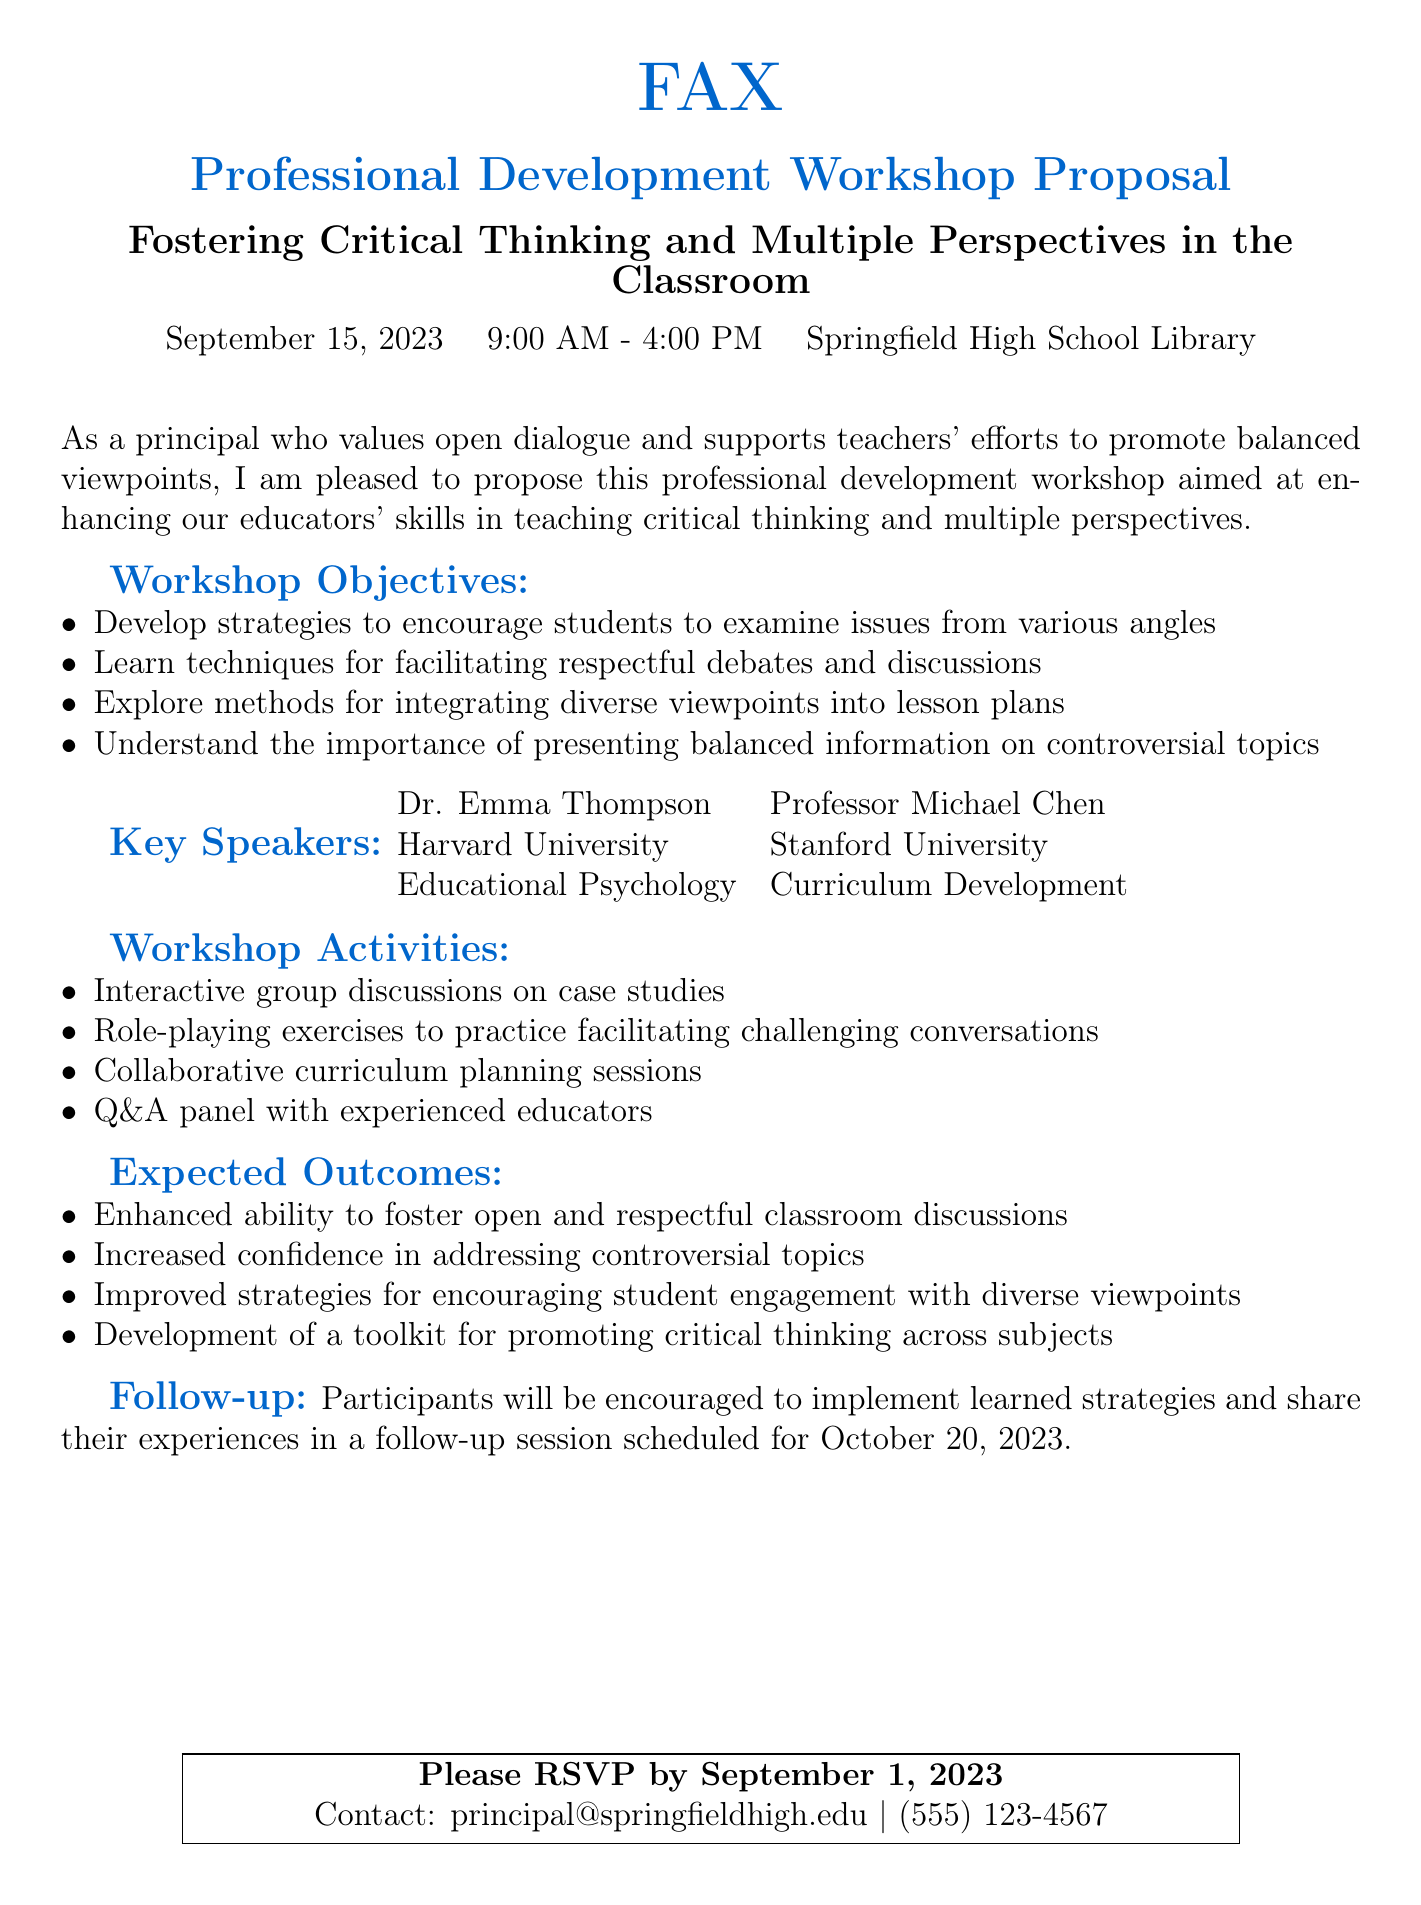What is the date of the workshop? The workshop is scheduled for September 15, 2023, as mentioned in the document.
Answer: September 15, 2023 What is the duration of the workshop? The workshop starts at 9:00 AM and ends at 4:00 PM, indicating a duration of 7 hours.
Answer: 7 hours Who is one of the key speakers? Dr. Emma Thompson is listed as one of the key speakers in the workshop proposal.
Answer: Dr. Emma Thompson What is one objective of the workshop? The document lists several objectives, one being to develop strategies to encourage students to examine issues from various angles.
Answer: Encourage students to examine issues from various angles What is the RSVP deadline? The document specifies that participants should RSVP by September 1, 2023.
Answer: September 1, 2023 Where will the workshop take place? The workshop is scheduled to be held in the Springfield High School Library.
Answer: Springfield High School Library What is a follow-up activity after the workshop? Participants will share their experiences in a follow-up session scheduled for October 20, 2023.
Answer: October 20, 2023 What type of exercises will be included in the workshop activities? The workshop includes role-playing exercises as part of its activities.
Answer: Role-playing exercises What is one expected outcome of the workshop? One expected outcome is an enhanced ability to foster open and respectful classroom discussions.
Answer: Enhanced ability to foster open and respectful classroom discussions 